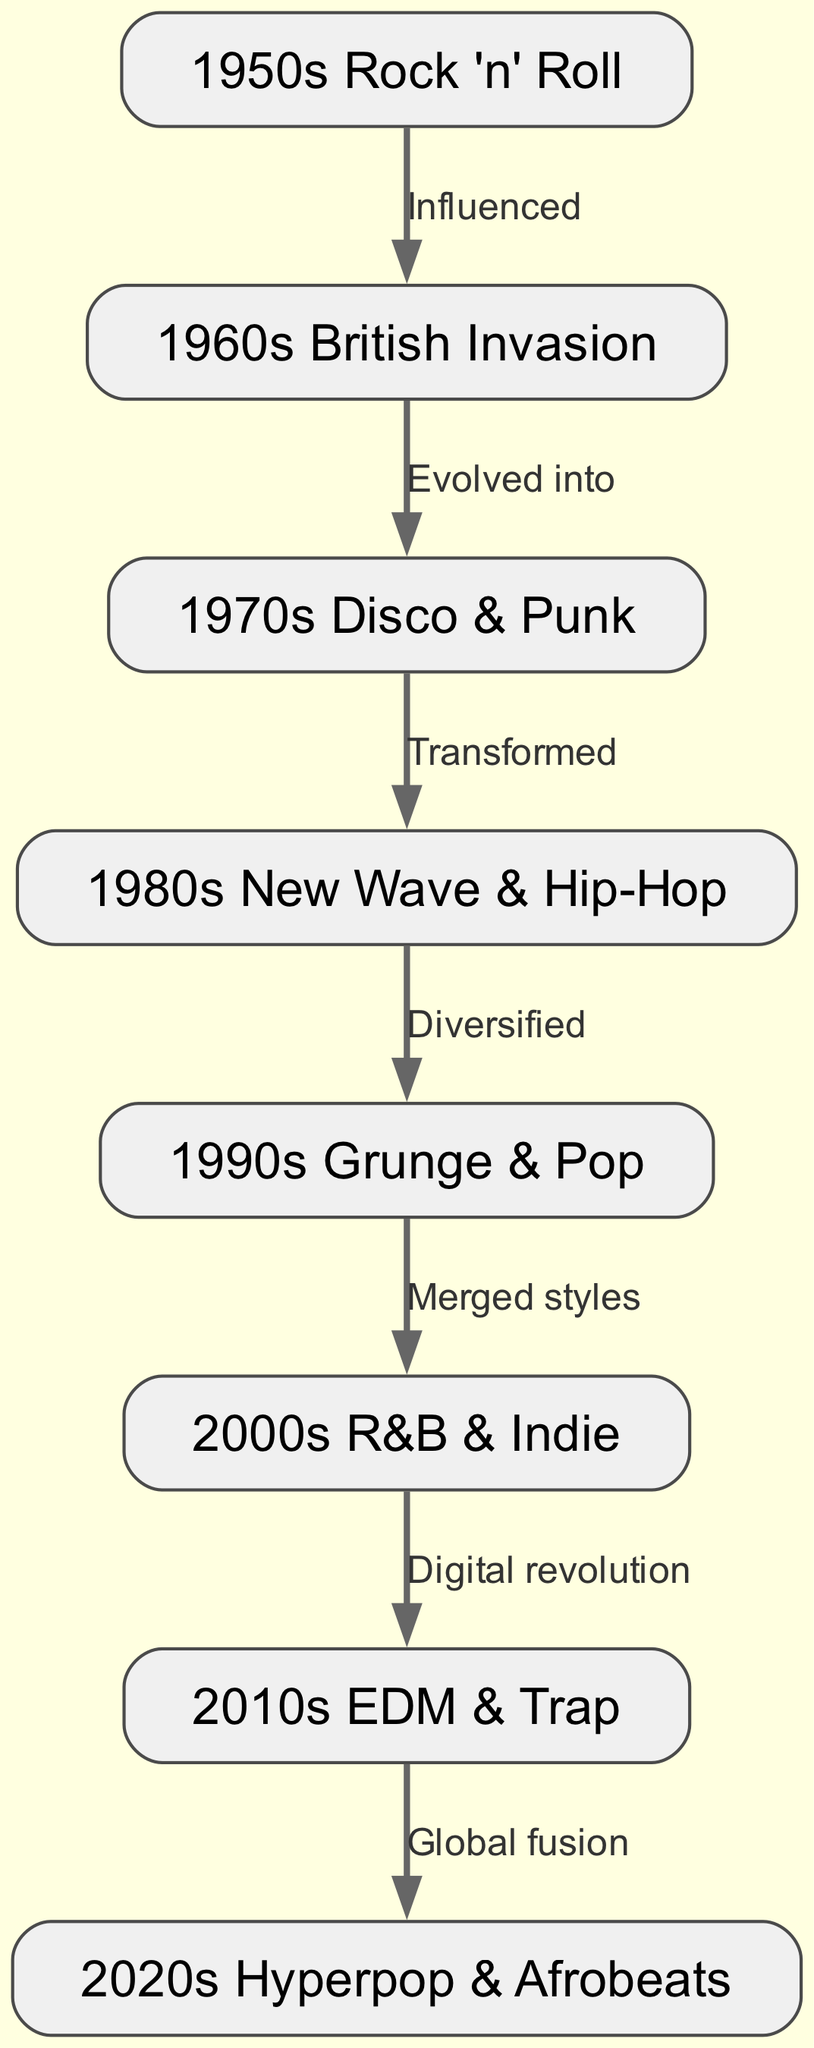What music genre is associated with the 1950s? The node labeled "1950s Rock 'n' Roll" directly corresponds to the 1950s era in the diagram.
Answer: 1950s Rock 'n' Roll How many nodes are in the diagram? Counting each unique node in the diagram reveals there are eight distinct music genre nodes listed from the 1950s to 2020s.
Answer: 8 What genre evolved into the 1970s Disco & Punk? The edge connecting the "1960s British Invasion" node to the "1970s Disco & Punk" node indicates that this transition describes the evolution of the music genre.
Answer: 1960s British Invasion What relationship exists between the 1980s New Wave & Hip-Hop and the 1990s Grunge & Pop? The edge connecting these two nodes shows the label "Diversified," indicating the nature of change from the 1980s to the 1990s.
Answer: Diversified What is a primary theme from the 2010s to the 2020s music genres? The edge indicates "Global fusion" as the connection label, showing the predominant characteristic of change between these two decades.
Answer: Global fusion Which decade introduced the concept of the Digital revolution in music? The edge between the "2000s R&B & Indie" node and the "2010s EDM & Trap" node indicates that the digital revolution began during the 2000s.
Answer: 2000s What genre is noted for merging styles during the 1990s? The node labeled "1990s Grunge & Pop" reflects the merging of various styles marked in the diagram.
Answer: 1990s Grunge & Pop Which genre from the 2020s is prominently highlighted in the diagram? The node labeled "2020s Hyperpop & Afrobeats" specifically denotes the current genres established in the 2020s.
Answer: 2020s Hyperpop & Afrobeats 